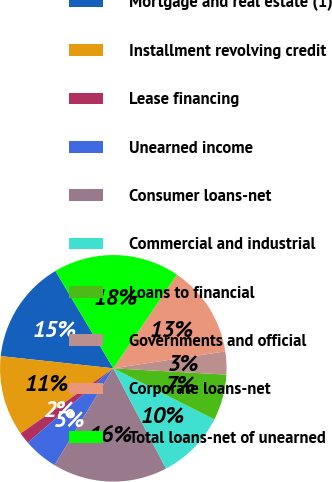<chart> <loc_0><loc_0><loc_500><loc_500><pie_chart><fcel>Mortgage and real estate (1)<fcel>Installment revolving credit<fcel>Lease financing<fcel>Unearned income<fcel>Consumer loans-net<fcel>Commercial and industrial<fcel>Loans to financial<fcel>Governments and official<fcel>Corporate loans-net<fcel>Total loans-net of unearned<nl><fcel>14.75%<fcel>11.48%<fcel>1.64%<fcel>4.92%<fcel>16.39%<fcel>9.84%<fcel>6.56%<fcel>3.28%<fcel>13.11%<fcel>18.03%<nl></chart> 